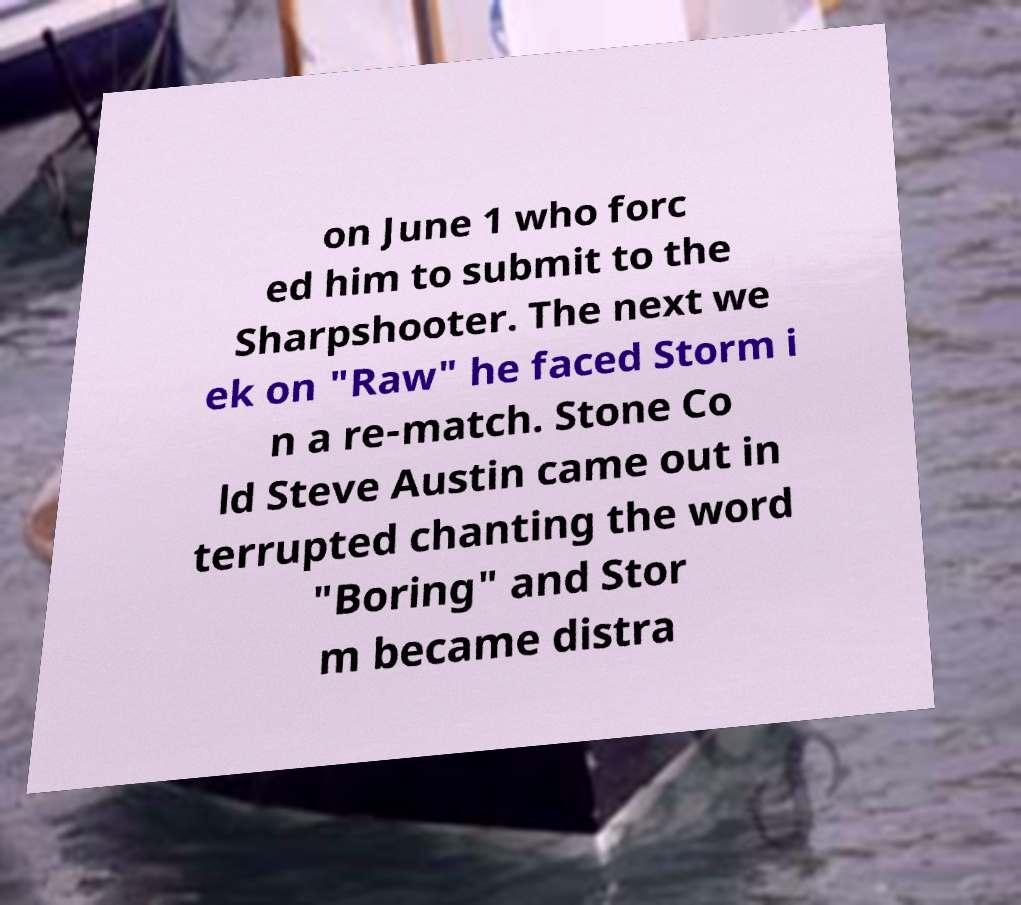Could you extract and type out the text from this image? on June 1 who forc ed him to submit to the Sharpshooter. The next we ek on "Raw" he faced Storm i n a re-match. Stone Co ld Steve Austin came out in terrupted chanting the word "Boring" and Stor m became distra 